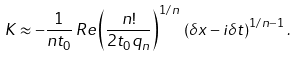<formula> <loc_0><loc_0><loc_500><loc_500>K \approx - \frac { 1 } { n t _ { 0 } } \, R e \left ( \frac { n ! } { 2 t _ { 0 } q _ { n } } \right ) ^ { 1 / n } \, \left ( \delta x - i \delta t \right ) ^ { 1 / n - 1 } .</formula> 